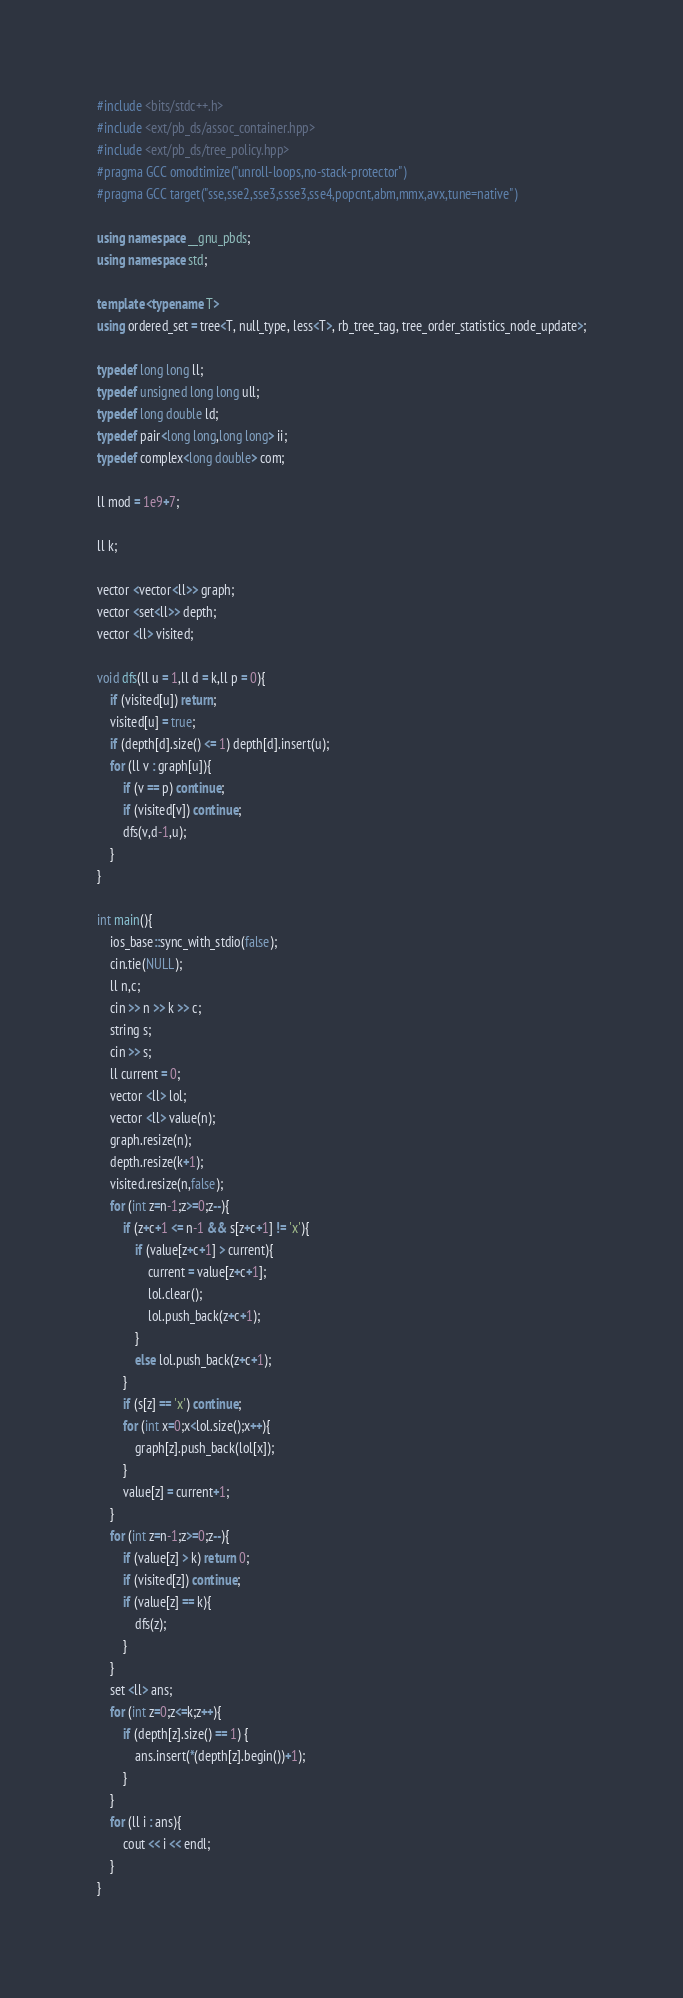Convert code to text. <code><loc_0><loc_0><loc_500><loc_500><_C++_>#include <bits/stdc++.h>
#include <ext/pb_ds/assoc_container.hpp>
#include <ext/pb_ds/tree_policy.hpp>
#pragma GCC omodtimize("unroll-loops,no-stack-protector")
#pragma GCC target("sse,sse2,sse3,ssse3,sse4,popcnt,abm,mmx,avx,tune=native")
 
using namespace __gnu_pbds;
using namespace std;
 
template <typename T>
using ordered_set = tree<T, null_type, less<T>, rb_tree_tag, tree_order_statistics_node_update>;
 
typedef long long ll;
typedef unsigned long long ull;
typedef long double ld;
typedef pair<long long,long long> ii; 	
typedef complex<long double> com;

ll mod = 1e9+7;

ll k;

vector <vector<ll>> graph;
vector <set<ll>> depth;
vector <ll> visited;

void dfs(ll u = 1,ll d = k,ll p = 0){
	if (visited[u]) return;
	visited[u] = true;
	if (depth[d].size() <= 1) depth[d].insert(u);
	for (ll v : graph[u]){
		if (v == p) continue;
		if (visited[v]) continue;
		dfs(v,d-1,u);
	}
}

int main(){
	ios_base::sync_with_stdio(false);
	cin.tie(NULL);
	ll n,c;
	cin >> n >> k >> c;
	string s;
	cin >> s;
	ll current = 0;
	vector <ll> lol;
	vector <ll> value(n);
	graph.resize(n);
	depth.resize(k+1);
	visited.resize(n,false);
	for (int z=n-1;z>=0;z--){
		if (z+c+1 <= n-1 && s[z+c+1] != 'x'){
			if (value[z+c+1] > current){
				current = value[z+c+1];
				lol.clear();
				lol.push_back(z+c+1);
			}
			else lol.push_back(z+c+1);
		}
		if (s[z] == 'x') continue;
		for (int x=0;x<lol.size();x++){
			graph[z].push_back(lol[x]);
		}
		value[z] = current+1;
	}
	for (int z=n-1;z>=0;z--){
		if (value[z] > k) return 0;
		if (visited[z]) continue;
		if (value[z] == k){
			dfs(z);
		}
	}
	set <ll> ans;
	for (int z=0;z<=k;z++){
		if (depth[z].size() == 1) {
			ans.insert(*(depth[z].begin())+1);
		}
	}
	for (ll i : ans){
		cout << i << endl;
	}
}</code> 